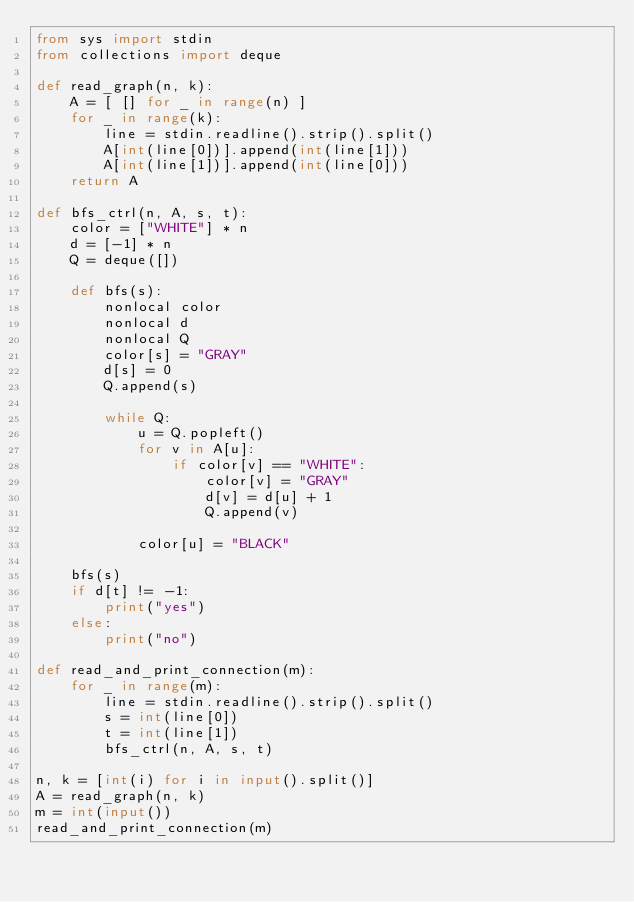<code> <loc_0><loc_0><loc_500><loc_500><_Python_>from sys import stdin
from collections import deque

def read_graph(n, k):
    A = [ [] for _ in range(n) ]
    for _ in range(k):
        line = stdin.readline().strip().split()
        A[int(line[0])].append(int(line[1]))
        A[int(line[1])].append(int(line[0]))
    return A

def bfs_ctrl(n, A, s, t):
    color = ["WHITE"] * n
    d = [-1] * n
    Q = deque([])

    def bfs(s):
        nonlocal color
        nonlocal d
        nonlocal Q
        color[s] = "GRAY"
        d[s] = 0
        Q.append(s)

        while Q:
            u = Q.popleft()
            for v in A[u]:
                if color[v] == "WHITE":
                    color[v] = "GRAY"
                    d[v] = d[u] + 1
                    Q.append(v)

            color[u] = "BLACK"

    bfs(s)
    if d[t] != -1:
        print("yes")
    else:
        print("no")

def read_and_print_connection(m):
    for _ in range(m):
        line = stdin.readline().strip().split()
        s = int(line[0])
        t = int(line[1])
        bfs_ctrl(n, A, s, t)

n, k = [int(i) for i in input().split()]
A = read_graph(n, k)
m = int(input())
read_and_print_connection(m)
</code> 